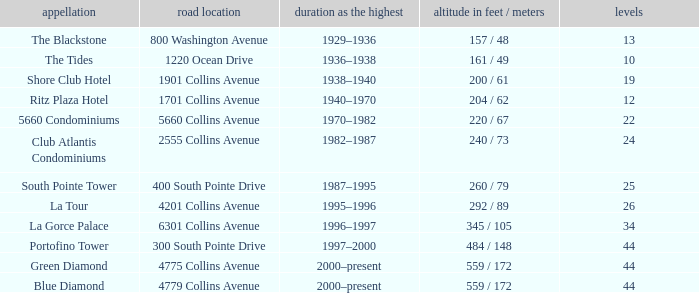How many floors does the Blue Diamond have? 44.0. 